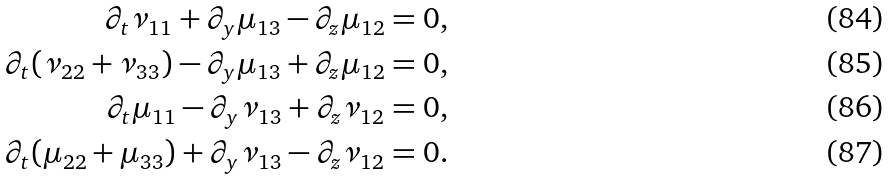Convert formula to latex. <formula><loc_0><loc_0><loc_500><loc_500>\partial _ { t } \nu _ { 1 1 } + \partial _ { y } \mu _ { 1 3 } - \partial _ { z } \mu _ { 1 2 } = 0 , \\ \partial _ { t } ( \nu _ { 2 2 } + \nu _ { 3 3 } ) - \partial _ { y } \mu _ { 1 3 } + \partial _ { z } \mu _ { 1 2 } = 0 , \\ \partial _ { t } \mu _ { 1 1 } - \partial _ { y } \nu _ { 1 3 } + \partial _ { z } \nu _ { 1 2 } = 0 , \\ \partial _ { t } ( \mu _ { 2 2 } + \mu _ { 3 3 } ) + \partial _ { y } \nu _ { 1 3 } - \partial _ { z } \nu _ { 1 2 } = 0 .</formula> 